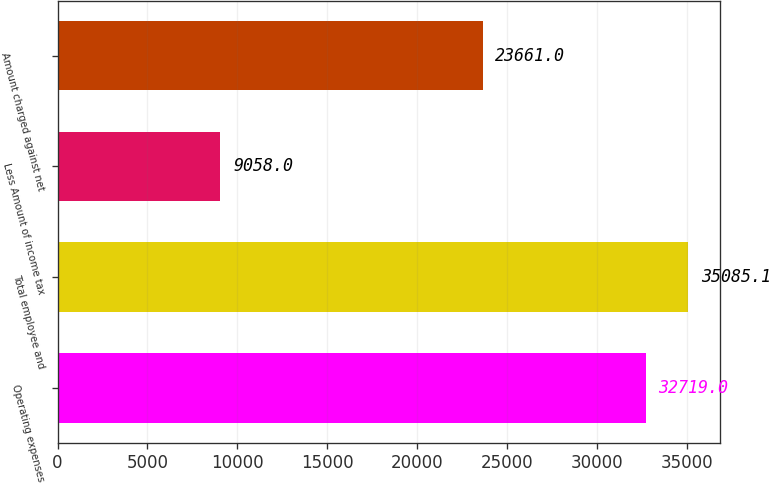Convert chart. <chart><loc_0><loc_0><loc_500><loc_500><bar_chart><fcel>Operating expenses<fcel>Total employee and<fcel>Less Amount of income tax<fcel>Amount charged against net<nl><fcel>32719<fcel>35085.1<fcel>9058<fcel>23661<nl></chart> 